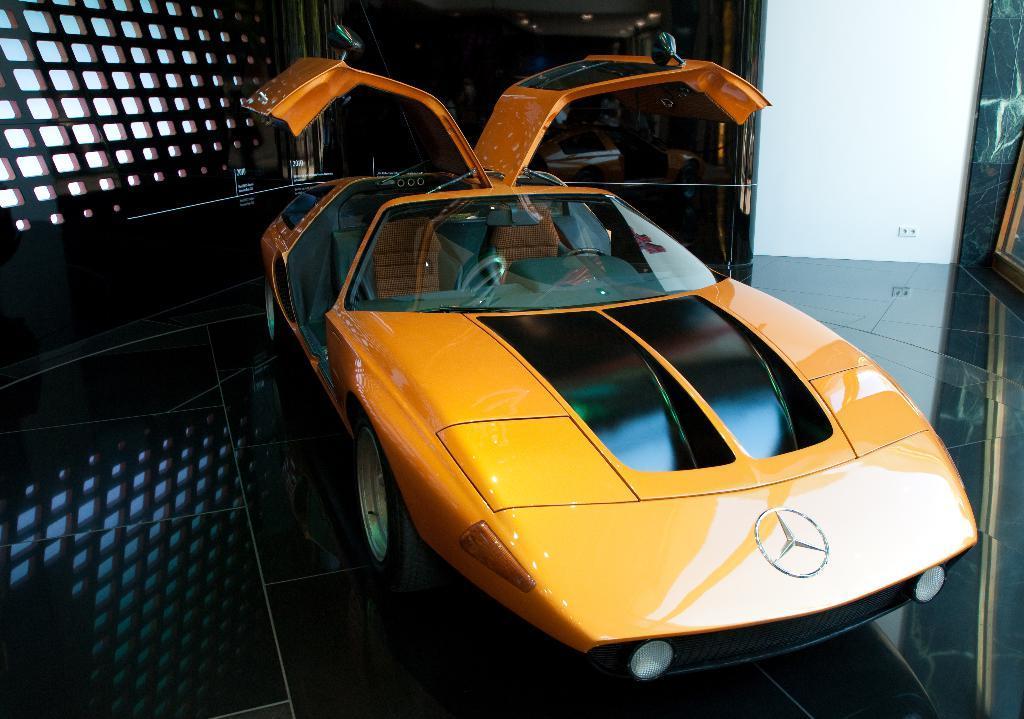Please provide a concise description of this image. There is a car with opened doors on a platform. In the back there is a window. 